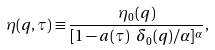<formula> <loc_0><loc_0><loc_500><loc_500>\eta ( { q } , \tau ) \equiv \frac { \eta _ { 0 } ( { q } ) } { [ 1 - a ( \tau ) \ \delta _ { 0 } ( { q } ) / \alpha ] ^ { \alpha } } ,</formula> 